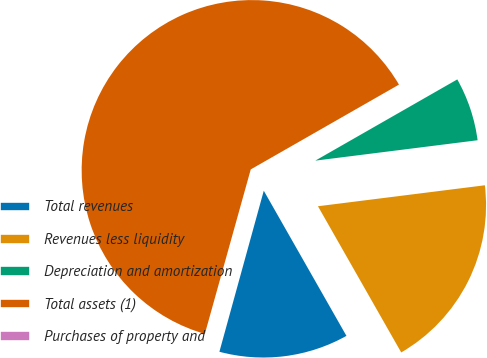Convert chart to OTSL. <chart><loc_0><loc_0><loc_500><loc_500><pie_chart><fcel>Total revenues<fcel>Revenues less liquidity<fcel>Depreciation and amortization<fcel>Total assets (1)<fcel>Purchases of property and<nl><fcel>12.52%<fcel>18.75%<fcel>6.28%<fcel>62.4%<fcel>0.05%<nl></chart> 